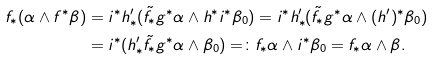<formula> <loc_0><loc_0><loc_500><loc_500>f _ { * } ( \alpha \wedge f ^ { * } \beta ) & = i ^ { * } h ^ { \prime } _ { * } ( \tilde { f } _ { * } g ^ { * } \alpha \wedge h ^ { * } i ^ { * } \beta _ { 0 } ) = i ^ { * } h ^ { \prime } _ { * } ( \tilde { f } _ { * } g ^ { * } \alpha \wedge ( h ^ { \prime } ) ^ { * } \beta _ { 0 } ) \\ & = i ^ { * } ( h ^ { \prime } _ { * } \tilde { f } _ { * } g ^ { * } \alpha \wedge \beta _ { 0 } ) = \colon f _ { * } \alpha \wedge i ^ { * } \beta _ { 0 } = f _ { * } \alpha \wedge \beta .</formula> 